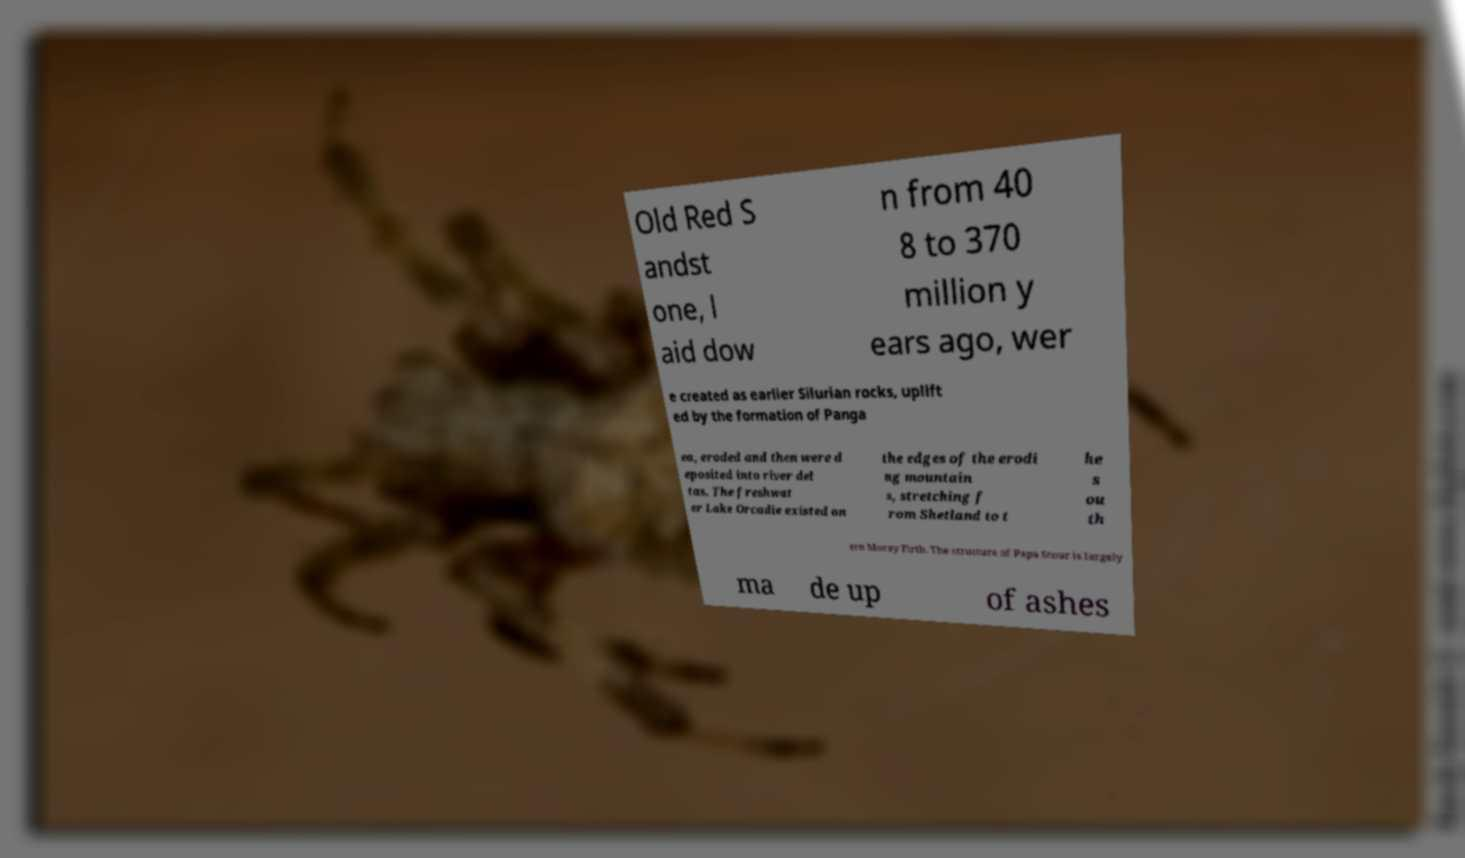Can you accurately transcribe the text from the provided image for me? Old Red S andst one, l aid dow n from 40 8 to 370 million y ears ago, wer e created as earlier Silurian rocks, uplift ed by the formation of Panga ea, eroded and then were d eposited into river del tas. The freshwat er Lake Orcadie existed on the edges of the erodi ng mountain s, stretching f rom Shetland to t he s ou th ern Moray Firth. The structure of Papa Stour is largely ma de up of ashes 